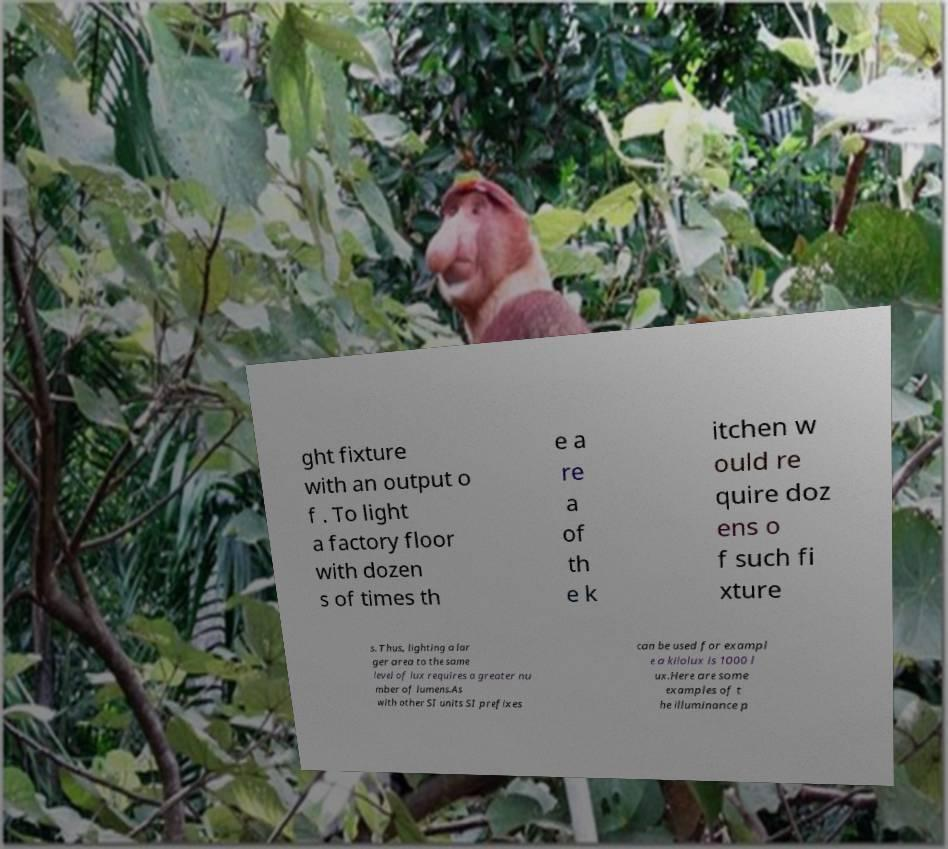Please read and relay the text visible in this image. What does it say? ght fixture with an output o f . To light a factory floor with dozen s of times th e a re a of th e k itchen w ould re quire doz ens o f such fi xture s. Thus, lighting a lar ger area to the same level of lux requires a greater nu mber of lumens.As with other SI units SI prefixes can be used for exampl e a kilolux is 1000 l ux.Here are some examples of t he illuminance p 